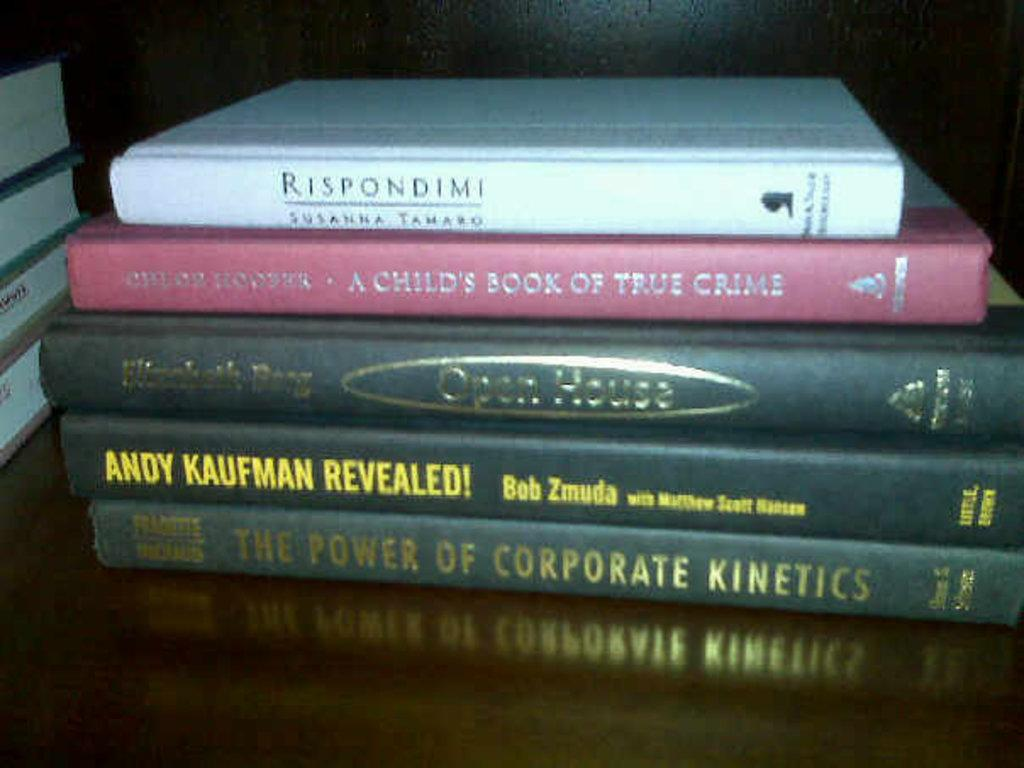Provide a one-sentence caption for the provided image. A hardcover book about Andy Kaufman sits in a stack with four other hardback books. 